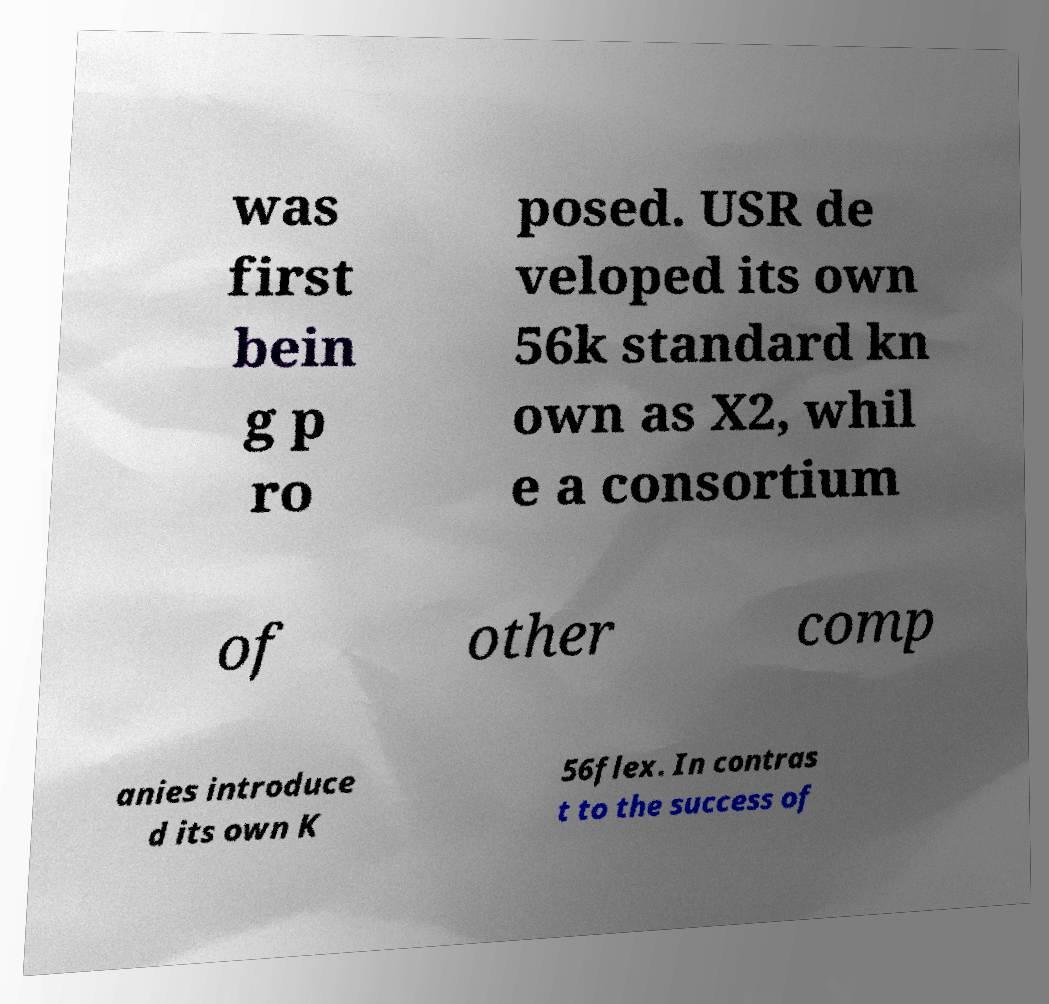Could you assist in decoding the text presented in this image and type it out clearly? was first bein g p ro posed. USR de veloped its own 56k standard kn own as X2, whil e a consortium of other comp anies introduce d its own K 56flex. In contras t to the success of 